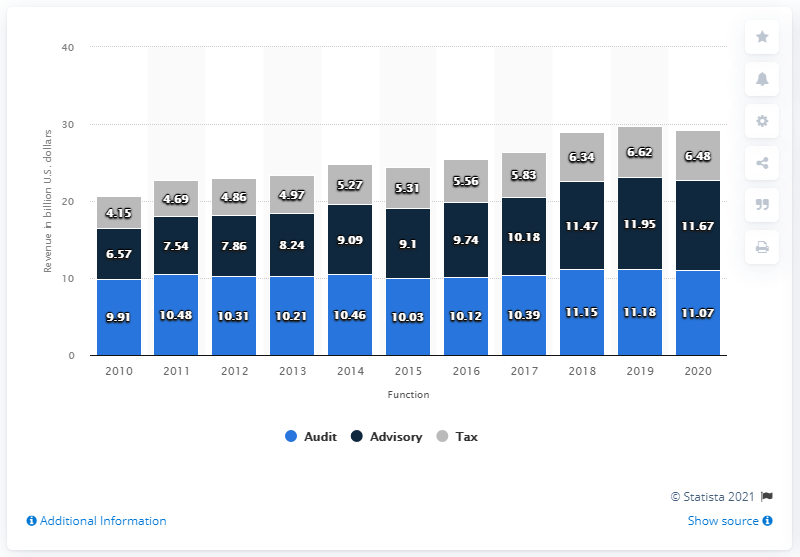Give some essential details in this illustration. In 2020, KPMG's advisory services in the U.S. generated approximately 11.67 million in revenue. 